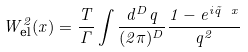Convert formula to latex. <formula><loc_0><loc_0><loc_500><loc_500>W _ { \text {el} } ^ { 2 } ( x ) = \frac { T } { \Gamma } \int \frac { d ^ { D } q } { ( 2 \pi ) ^ { D } } \frac { 1 - e ^ { i \vec { q } \ x } } { q ^ { 2 } }</formula> 